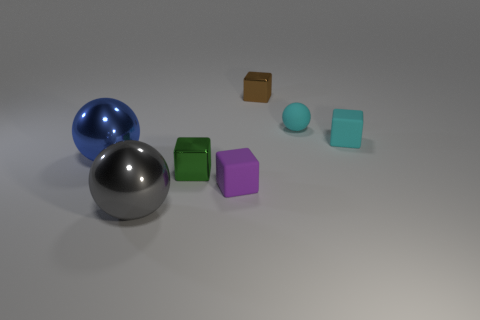Are there any other things that have the same size as the blue object?
Make the answer very short. Yes. What is the material of the tiny thing that is the same color as the tiny ball?
Provide a succinct answer. Rubber. Are there the same number of small cyan matte objects in front of the big gray object and gray objects?
Ensure brevity in your answer.  No. Are there any big shiny balls right of the blue object?
Offer a terse response. Yes. Do the blue object and the large object in front of the tiny purple cube have the same shape?
Offer a very short reply. Yes. What color is the large object that is made of the same material as the large blue ball?
Keep it short and to the point. Gray. What color is the tiny ball?
Ensure brevity in your answer.  Cyan. Is the large gray ball made of the same material as the tiny cyan thing left of the tiny cyan cube?
Offer a terse response. No. What number of things are both behind the tiny purple rubber cube and left of the tiny brown object?
Give a very brief answer. 2. What shape is the other thing that is the same size as the blue metal thing?
Your response must be concise. Sphere. 